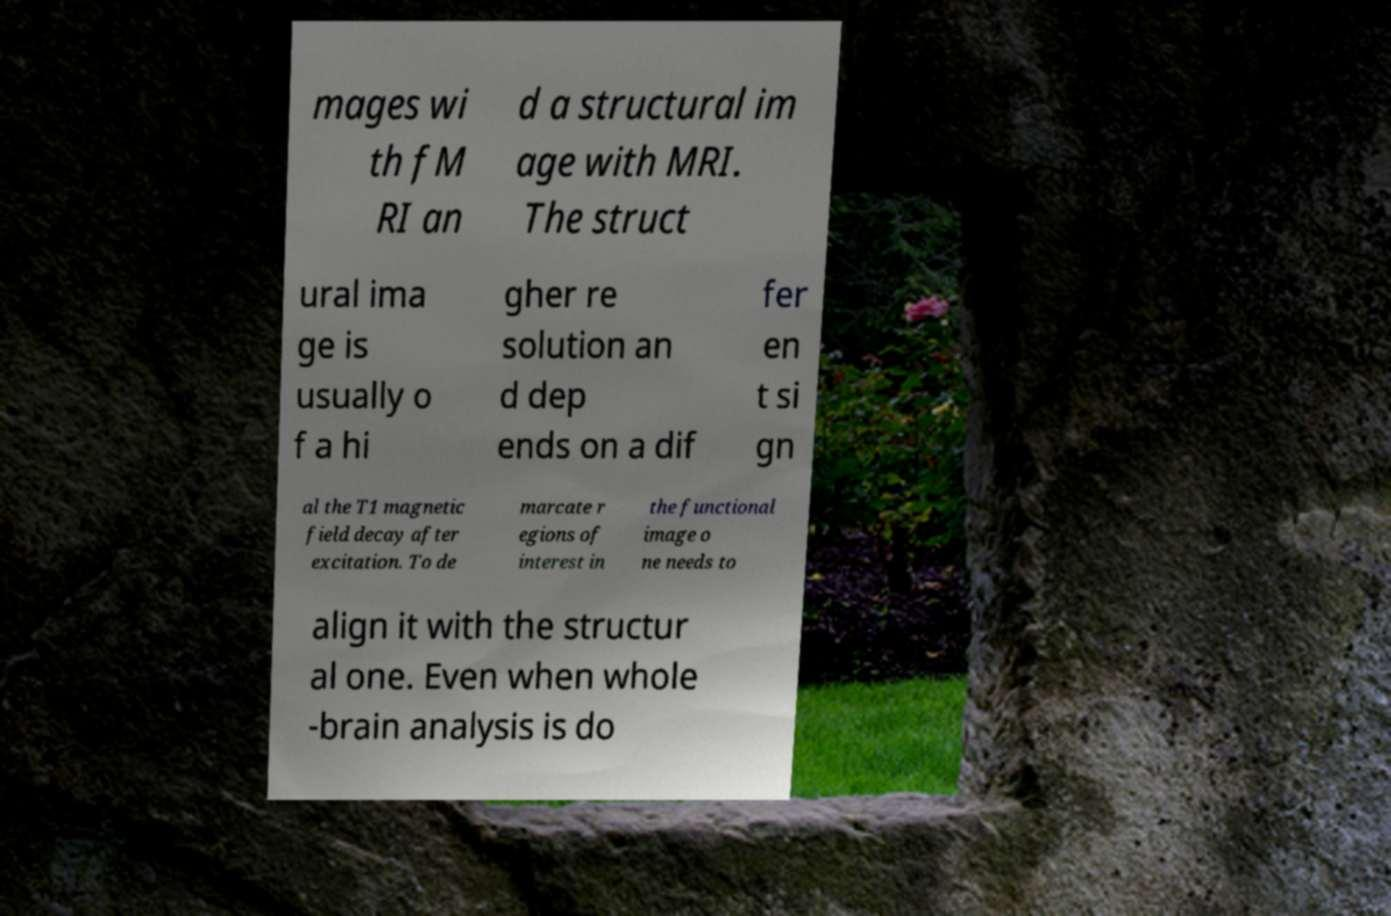What messages or text are displayed in this image? I need them in a readable, typed format. mages wi th fM RI an d a structural im age with MRI. The struct ural ima ge is usually o f a hi gher re solution an d dep ends on a dif fer en t si gn al the T1 magnetic field decay after excitation. To de marcate r egions of interest in the functional image o ne needs to align it with the structur al one. Even when whole -brain analysis is do 